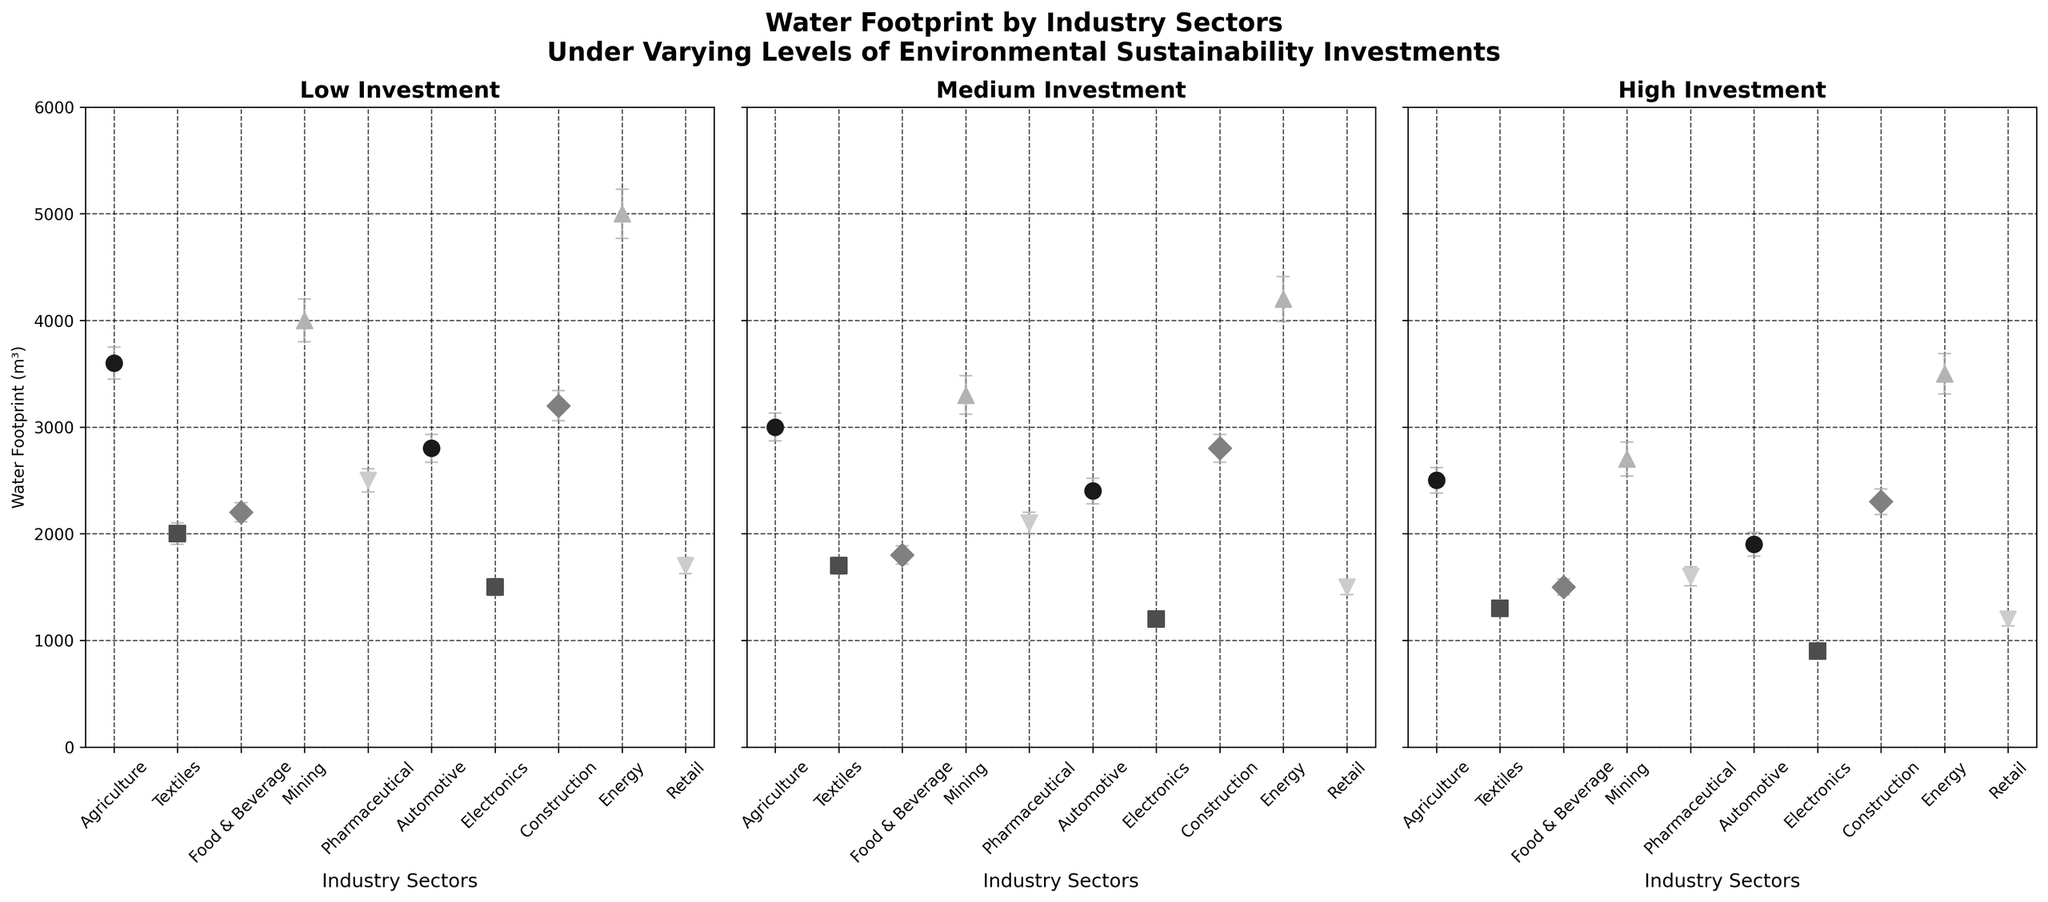What is the title of the figure? The title of the figure is generally placed at the top and is large, bold, and descriptive. It reads 'Water Footprint by Industry Sectors Under Varying Levels of Environmental Sustainability Investments'.
Answer: Water Footprint by Industry Sectors Under Varying Levels of Environmental Sustainability Investments How do the water footprints of the Energy and Agriculture sectors compare under low investment? Look at the first subplot for low investment. The Energy sector has a mean water footprint of 5000 m³, whereas Agriculture has a mean water footprint of 3600 m³.
Answer: Energy has a higher water footprint Which industry sector shows the greatest reduction in water footprint when moving from low to high investment? Calculate the differences for each sector between low and high investment. For example, the difference for Agriculture is 3600 - 2500 = 1100 m³. Find the largest difference this way. Energy's footprint drops from 5000 to 3500, a 1500 m³ reduction.
Answer: Energy What is the mean water footprint of the Retail sector under medium investment? In the subplot labeled "Medium Investment", find the point corresponding to Retail. The mean value is annotated as 1500 m³.
Answer: 1500 m³ Which sector has the smallest variability in water footprint under high investment? The smallest variability can be interpreted as the smallest standard deviation under high investment. Look for the smallest error bar in the high investment subplot. The Retail sector has the smallest error bar with a standard deviation of 65 m³.
Answer: Retail What is the mean water footprint of the Food & Beverage industry under different investment levels? Extract the means from each subplot for the Food & Beverage industry. These are: 2200 m³ for low, 1800 m³ for medium, and 1500 m³ for high investment.
Answer: 2200, 1800, 1500 m³ Which industry sector consistently reduces its water footprint with increased investment? Check each sector across the three subplots to see if their mean values consistently decrease. All sectors show decreases, but notably Agriculture, Textiles, and Energy show consistent decreases.
Answer: Agriculture, Textiles, Energy What is the average water footprint of the Mining sector across all investment levels? Add mean water footprints for the Mining sector: 4000 m³ (low) + 3300 m³ (medium) + 2700 m³ (high). Then, divide by 3.
Answer: (4000 + 3300 + 2700) / 3 = 3333.33 m³ Which two industry sectors have error bars that overlap the least in medium investment? Overlapping error bars indicate variability. Sectors with distinct, non-overlapping bars in medium investment should ideally be compared. Automotive and Pharmaceuticals show minimal overlap in the medium investment subplot.
Answer: Automotive and Pharmaceuticals By how much does the water footprint of the Electronics sector reduce when moving from low to high investment? Calculate the difference between the low and high investment means for Electronics: 1500 m³ (low) - 900 m³ (high).
Answer: 600 m³ 